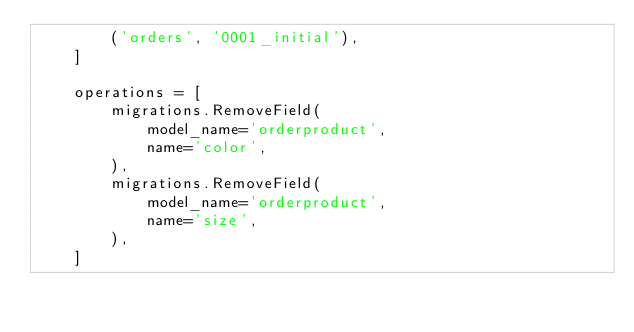<code> <loc_0><loc_0><loc_500><loc_500><_Python_>        ('orders', '0001_initial'),
    ]

    operations = [
        migrations.RemoveField(
            model_name='orderproduct',
            name='color',
        ),
        migrations.RemoveField(
            model_name='orderproduct',
            name='size',
        ),
    ]
</code> 